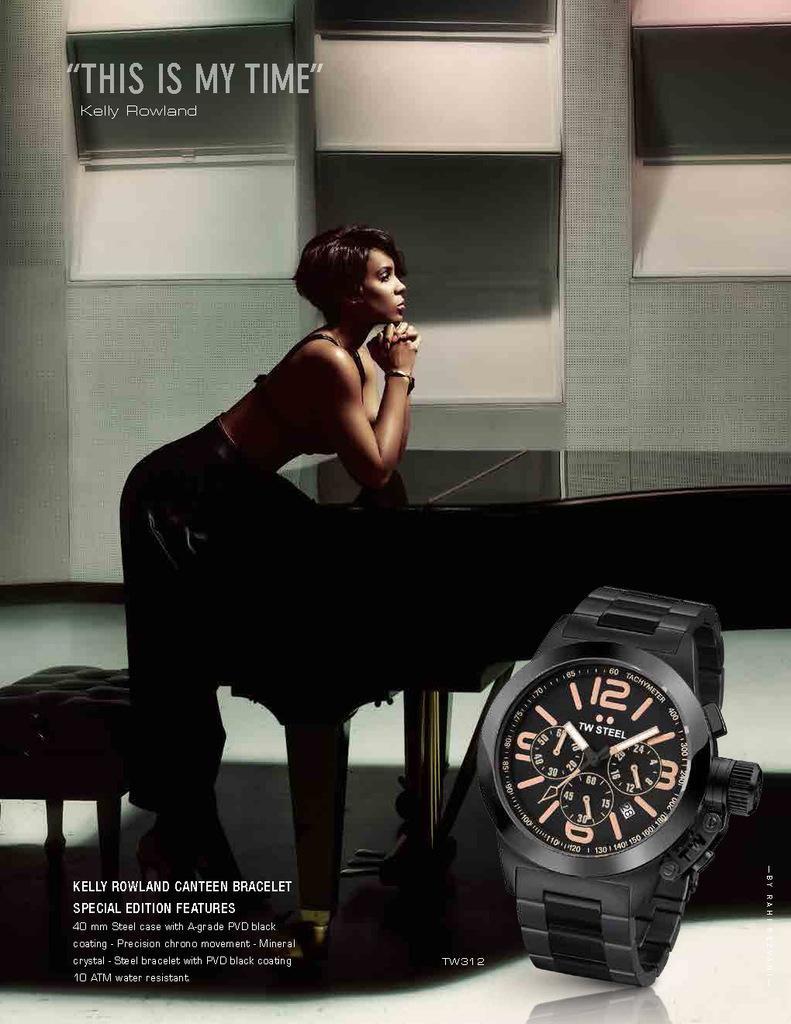Describe this image in one or two sentences. This is a poster. In this picture there is a woman standing. There is a musical instrument and there is a stool. At the back there is a wall. At the top left there is a text. At the bottom there is a picture of a watch. At the bottom left there is a text. 